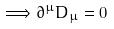Convert formula to latex. <formula><loc_0><loc_0><loc_500><loc_500>\Longrightarrow \partial ^ { \mu } D _ { \mu } = 0</formula> 